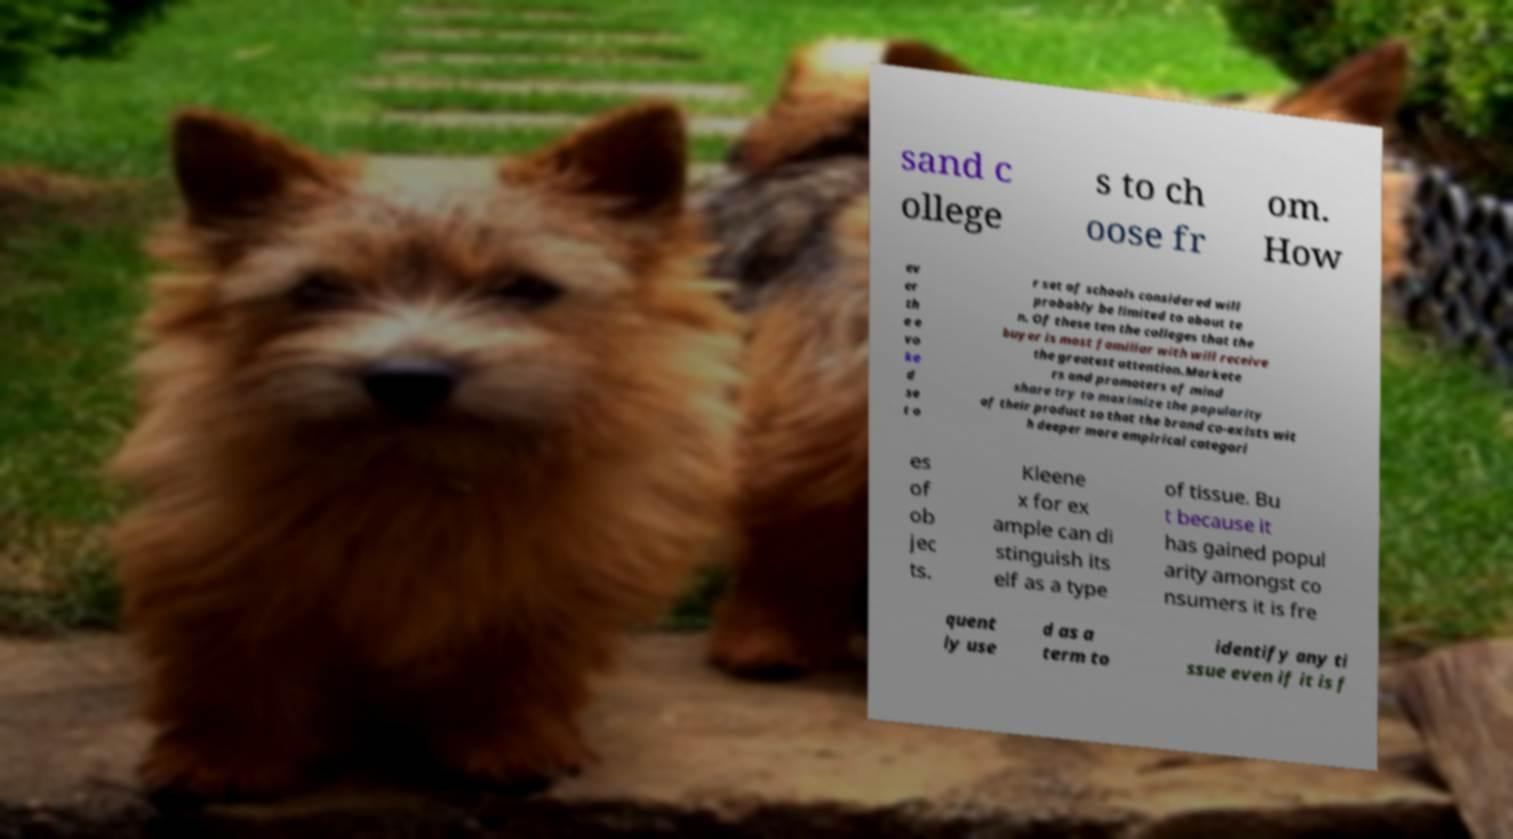Could you assist in decoding the text presented in this image and type it out clearly? sand c ollege s to ch oose fr om. How ev er th e e vo ke d se t o r set of schools considered will probably be limited to about te n. Of these ten the colleges that the buyer is most familiar with will receive the greatest attention.Markete rs and promoters of mind share try to maximize the popularity of their product so that the brand co-exists wit h deeper more empirical categori es of ob jec ts. Kleene x for ex ample can di stinguish its elf as a type of tissue. Bu t because it has gained popul arity amongst co nsumers it is fre quent ly use d as a term to identify any ti ssue even if it is f 